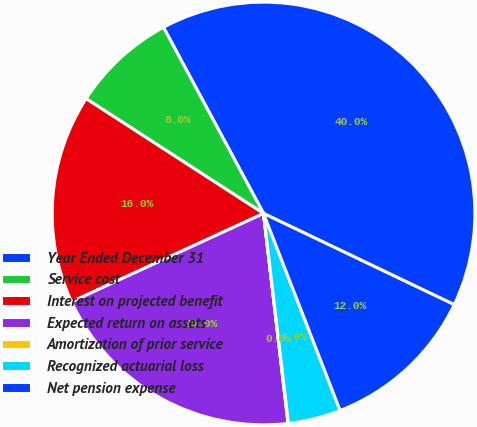Convert chart. <chart><loc_0><loc_0><loc_500><loc_500><pie_chart><fcel>Year Ended December 31<fcel>Service cost<fcel>Interest on projected benefit<fcel>Expected return on assets<fcel>Amortization of prior service<fcel>Recognized actuarial loss<fcel>Net pension expense<nl><fcel>39.95%<fcel>8.01%<fcel>16.0%<fcel>19.99%<fcel>0.03%<fcel>4.02%<fcel>12.0%<nl></chart> 